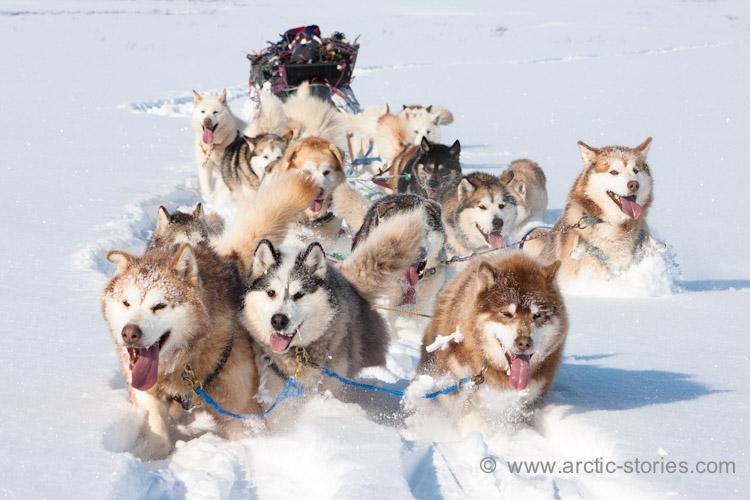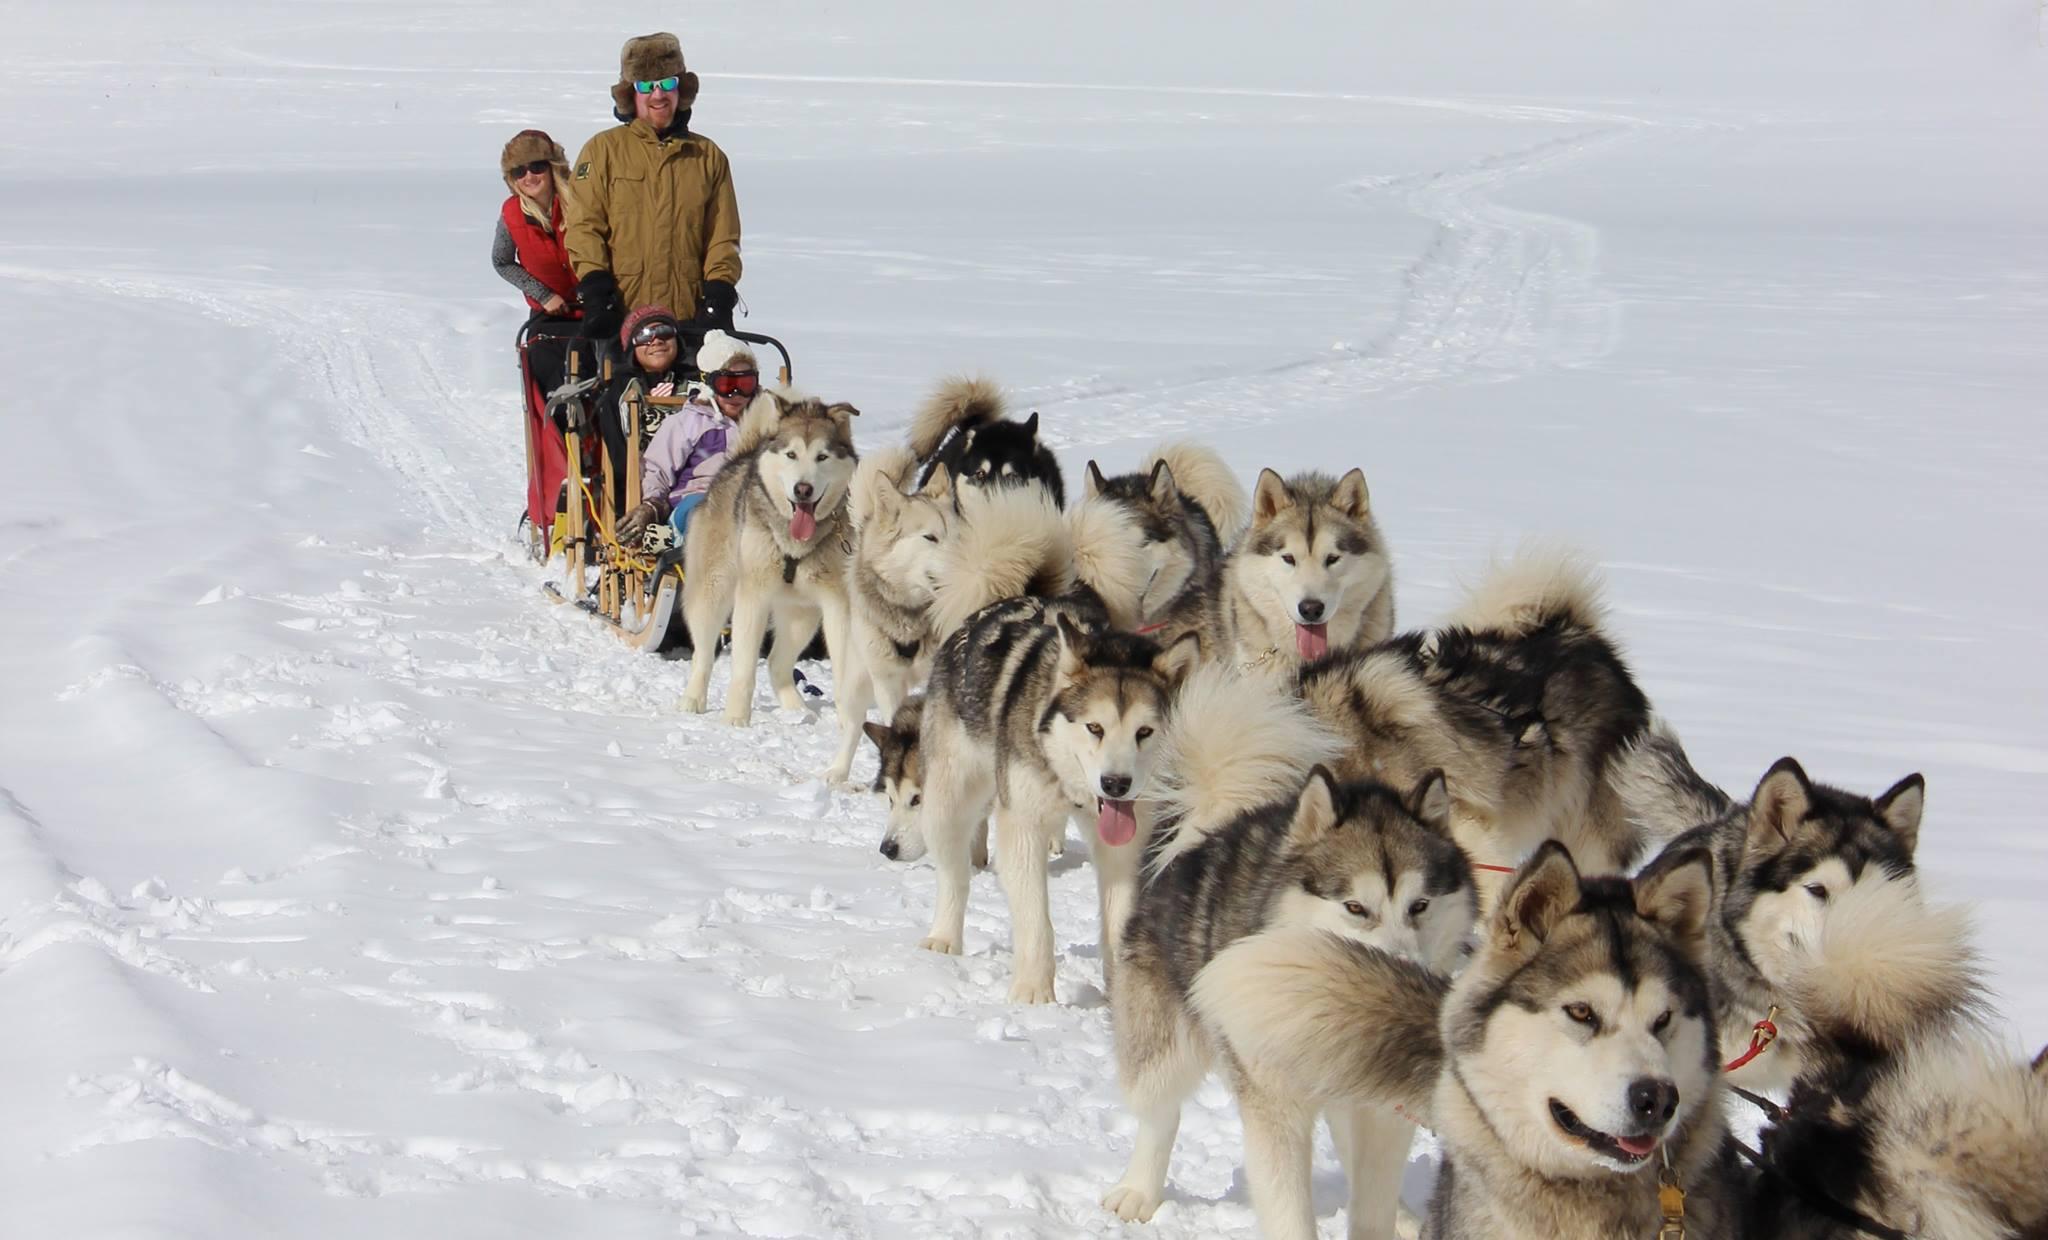The first image is the image on the left, the second image is the image on the right. For the images shown, is this caption "One dog team with a sled driver standing in back is headed forward and to the left down snowy ground with no bystanders." true? Answer yes or no. No. The first image is the image on the left, the second image is the image on the right. Given the left and right images, does the statement "There are only two dogs pulling one of the sleds." hold true? Answer yes or no. No. 